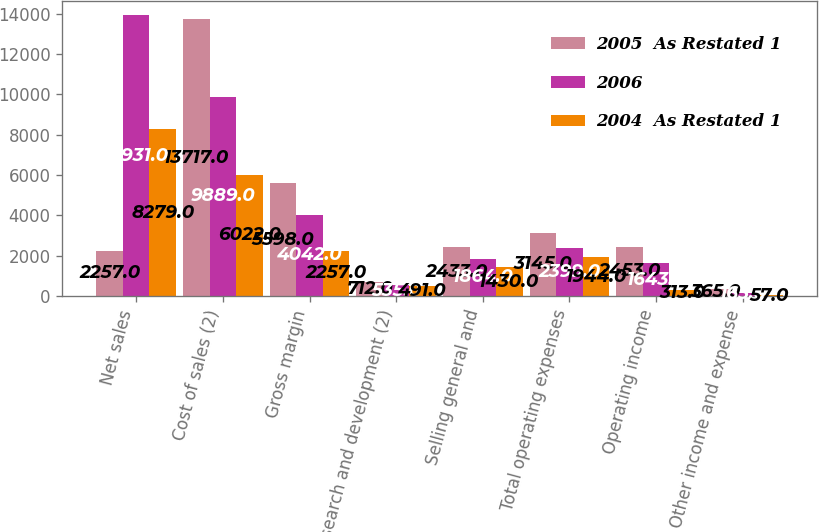<chart> <loc_0><loc_0><loc_500><loc_500><stacked_bar_chart><ecel><fcel>Net sales<fcel>Cost of sales (2)<fcel>Gross margin<fcel>Research and development (2)<fcel>Selling general and<fcel>Total operating expenses<fcel>Operating income<fcel>Other income and expense<nl><fcel>2005  As Restated 1<fcel>2257<fcel>13717<fcel>5598<fcel>712<fcel>2433<fcel>3145<fcel>2453<fcel>365<nl><fcel>2006<fcel>13931<fcel>9889<fcel>4042<fcel>535<fcel>1864<fcel>2399<fcel>1643<fcel>165<nl><fcel>2004  As Restated 1<fcel>8279<fcel>6022<fcel>2257<fcel>491<fcel>1430<fcel>1944<fcel>313<fcel>57<nl></chart> 